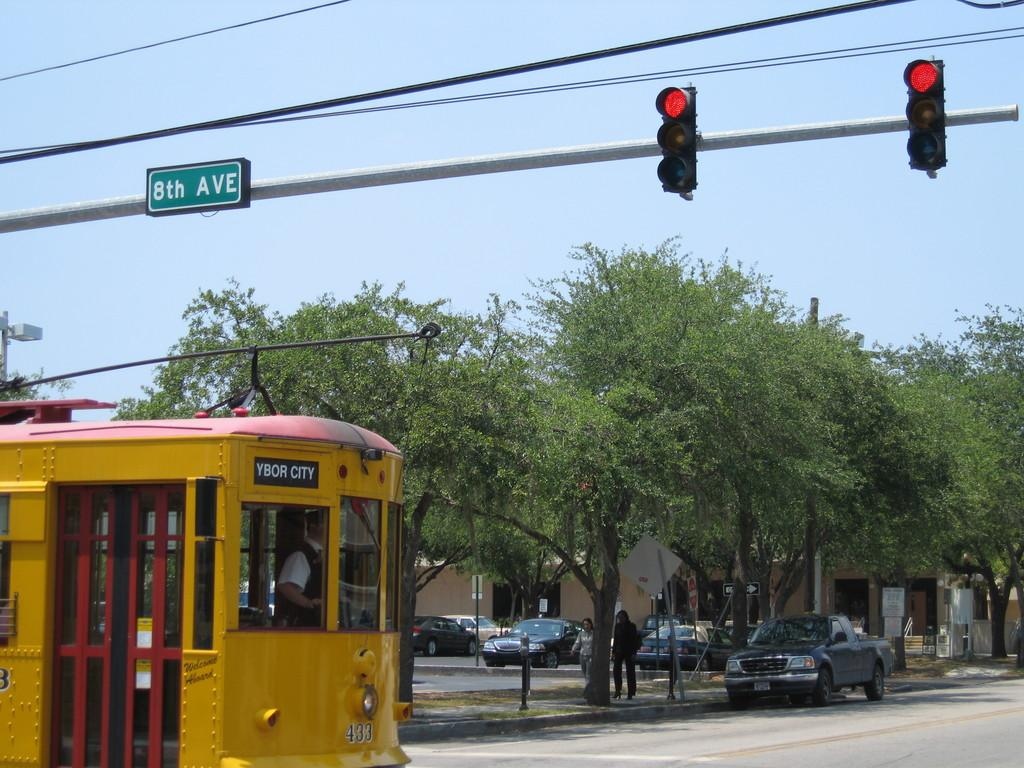<image>
Render a clear and concise summary of the photo. Trolley Bus Ybor City, passing an interaction where there is a Red Light showing. 